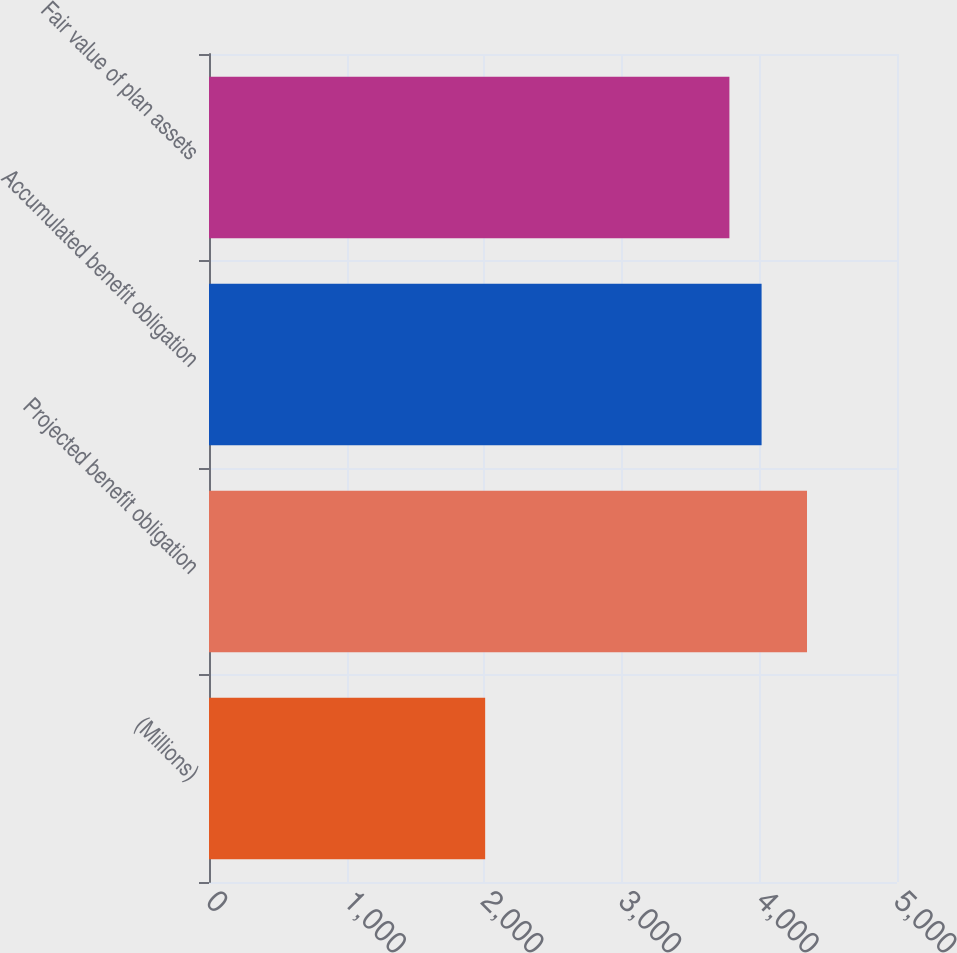<chart> <loc_0><loc_0><loc_500><loc_500><bar_chart><fcel>(Millions)<fcel>Projected benefit obligation<fcel>Accumulated benefit obligation<fcel>Fair value of plan assets<nl><fcel>2007<fcel>4346<fcel>4015.9<fcel>3782<nl></chart> 